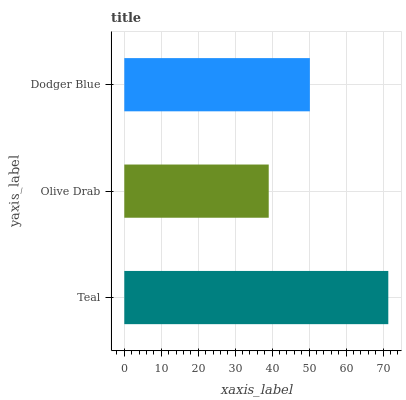Is Olive Drab the minimum?
Answer yes or no. Yes. Is Teal the maximum?
Answer yes or no. Yes. Is Dodger Blue the minimum?
Answer yes or no. No. Is Dodger Blue the maximum?
Answer yes or no. No. Is Dodger Blue greater than Olive Drab?
Answer yes or no. Yes. Is Olive Drab less than Dodger Blue?
Answer yes or no. Yes. Is Olive Drab greater than Dodger Blue?
Answer yes or no. No. Is Dodger Blue less than Olive Drab?
Answer yes or no. No. Is Dodger Blue the high median?
Answer yes or no. Yes. Is Dodger Blue the low median?
Answer yes or no. Yes. Is Teal the high median?
Answer yes or no. No. Is Teal the low median?
Answer yes or no. No. 